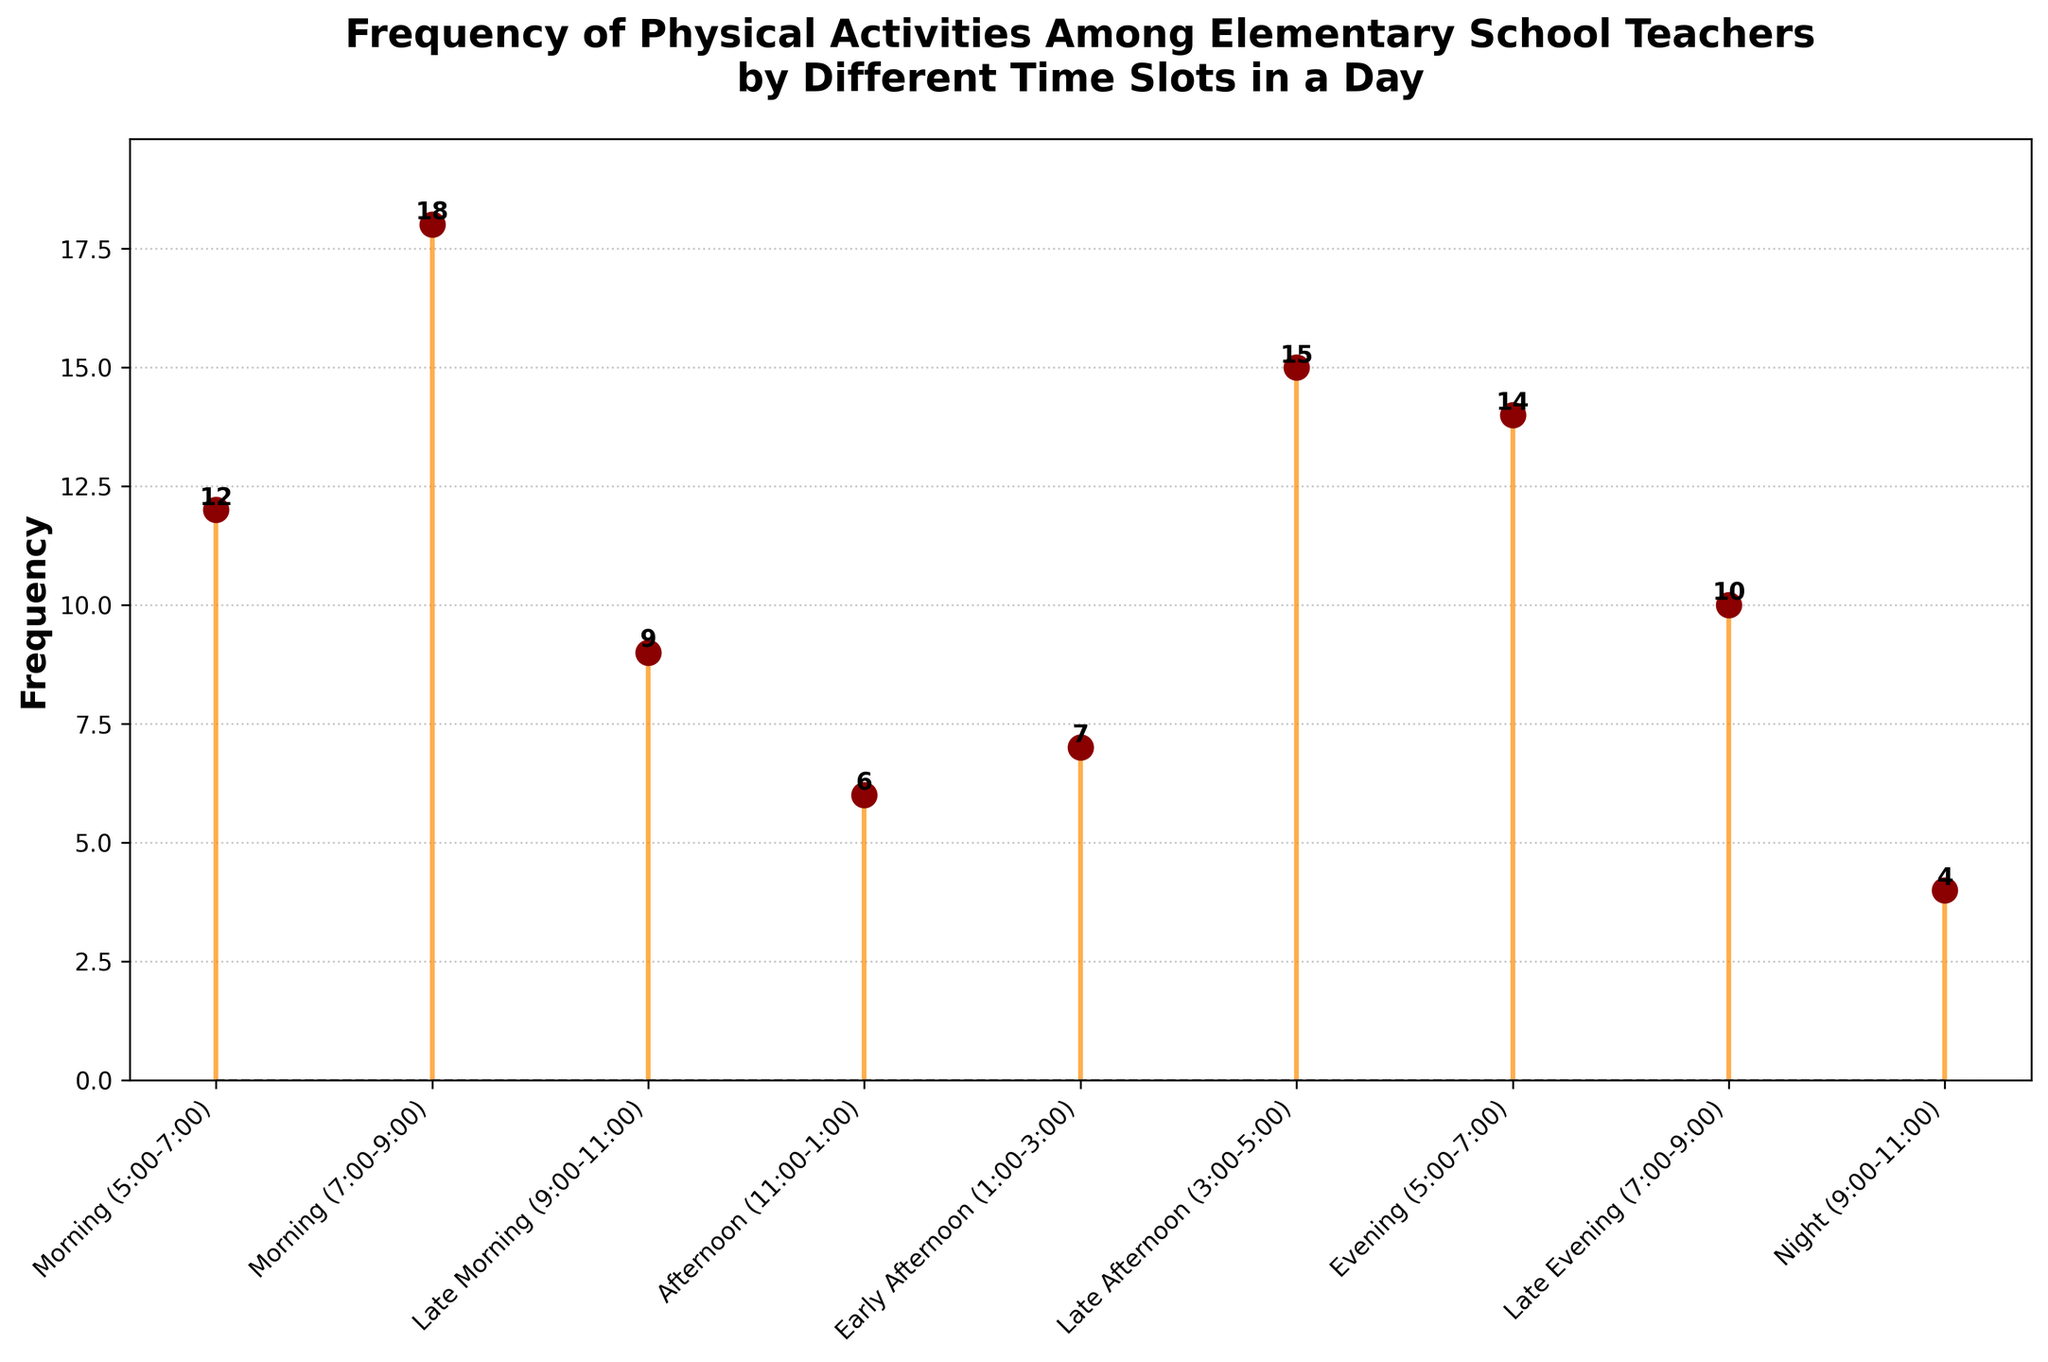What's the title of the figure? The title of the figure is usually displayed at the top and it's written in bold. The title gives an overview of what the plot depicts. In this case, the title should be located at the top in a larger font size compared to other texts.
Answer: Frequency of Physical Activities Among Elementary School Teachers by Different Time Slots in a Day How many time slots are there in a day according to the figure? By counting the distinct labels along the x-axis, we can determine the number of time slots. Each mark represents a different time slot.
Answer: 9 Which time slot has the highest frequency of physical activities? To find this, locate the stem with the highest marker on the y-axis. The corresponding label on the x-axis will indicate the time slot.
Answer: Morning (7:00-9:00) What's the frequency of physical activities in the Late Afternoon (3:00-5:00) time slot? Identify the stem corresponding to the Late Afternoon (3:00-5:00) on the x-axis and read the value from the y-axis.
Answer: 15 What is the difference in frequency of physical activities between the Morning (7:00-9:00) and Night (9:00-11:00) time slots? First, determine the frequencies corresponding to Morning (7:00-9:00) and Night (9:00-11:00), then subtract the latter from the former (18 - 4).
Answer: 14 During which time slot is the frequency of physical activities equal to 14? Locate the marker on the y-axis that corresponds to a value of 14 and then find the matching time slot on the x-axis.
Answer: Evening (5:00-7:00) Which time slots have a frequency of less than 10? Inspect the stems and find those whose markers are below the 10-unit mark on the y-axis. Identify the corresponding labels on the x-axis.
Answer: Late Morning (9:00-11:00), Afternoon (11:00-1:00), Early Afternoon (1:00-3:00), Night (9:00-11:00) What is the average frequency of physical activities across all listed time slots? Sum all the frequency values and divide by the total number of time slots (12+18+9+6+7+15+14+10+4). The total is 95, and there are 9 time slots, so the average is 95/9.
Answer: 10.56 Compare the frequency of physical activities in the Late Morning (9:00-11:00) and Early Afternoon (1:00-3:00) time slots. Which one is higher? Locate both time slots on the x-axis and compare the heights of their respective markers on the y-axis.
Answer: Late Morning (9:00-11:00) What's the sum of frequencies for all morning time slots combined? Identify the frequencies for all morning time slots (12 from 5:00-7:00, 18 from 7:00-9:00, and 9 from 9:00-11:00) and then sum them up (12 + 18 + 9).
Answer: 39 